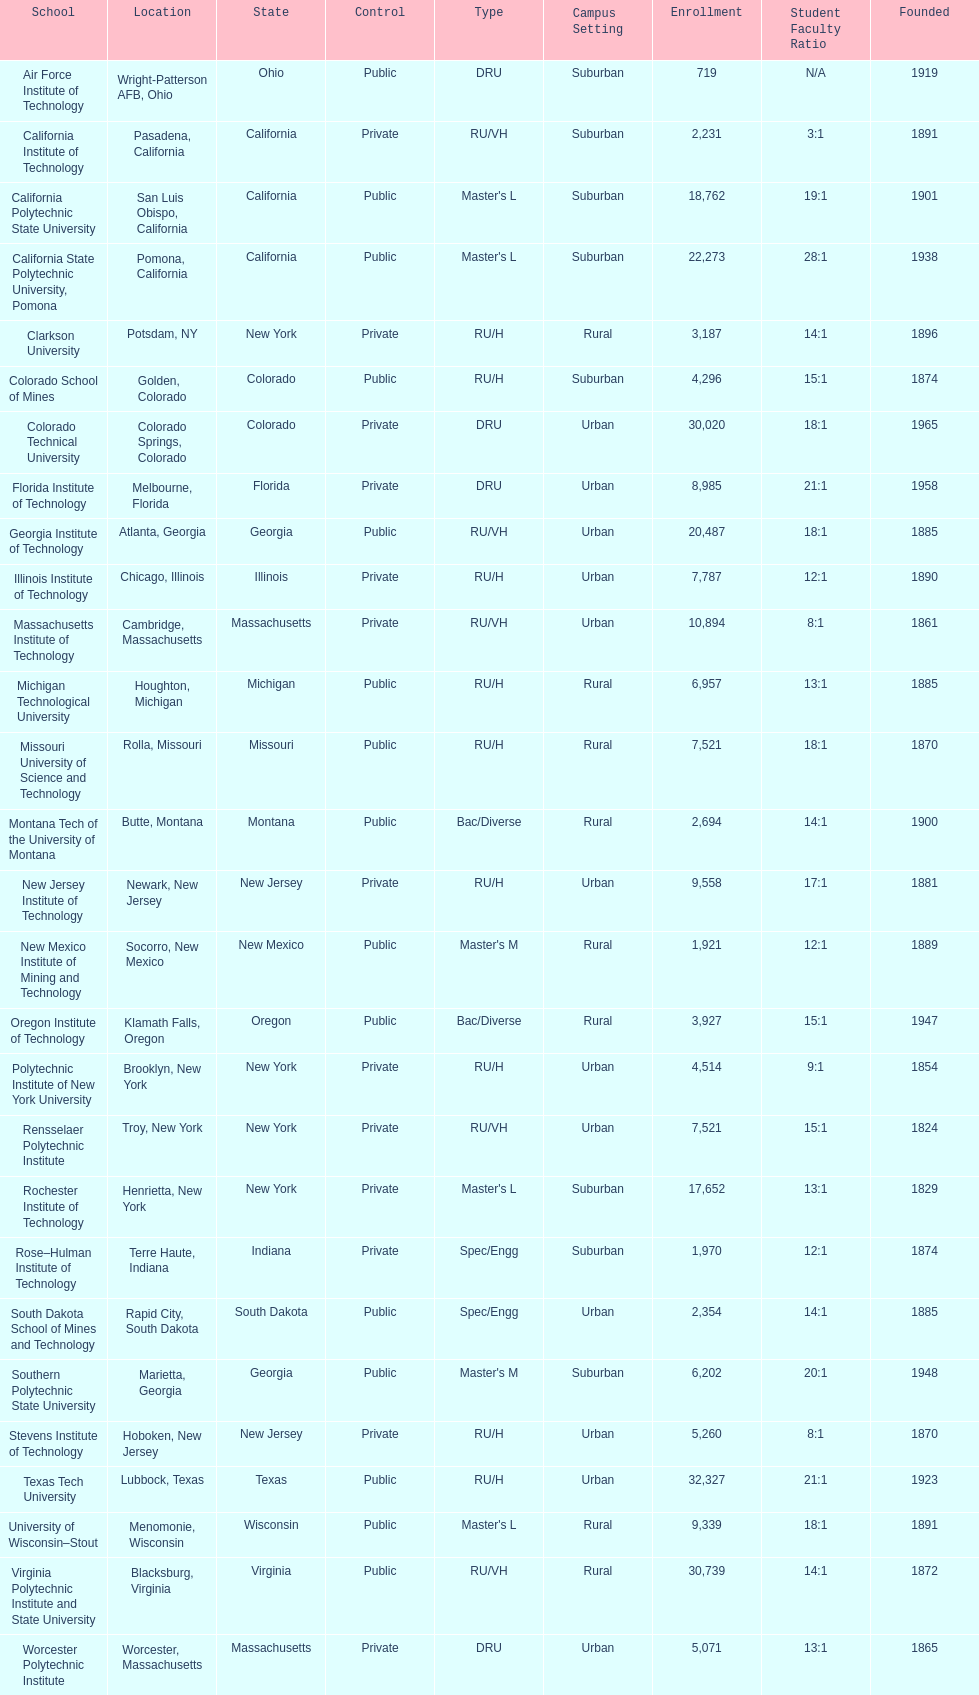What is the total number of schools listed in the table? 28. 